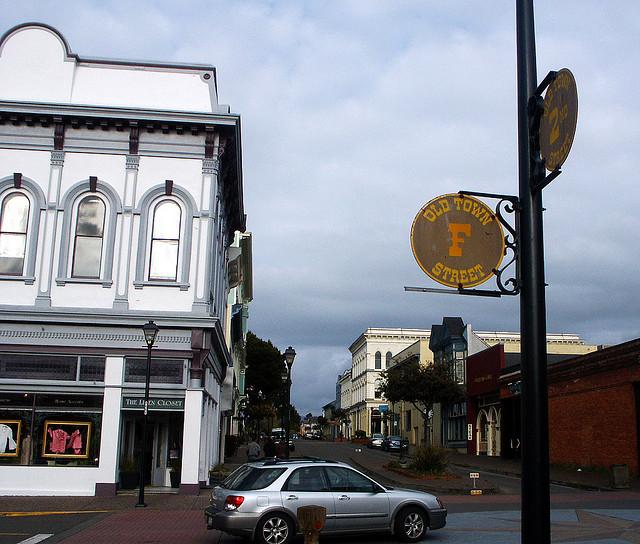What color is the car?
Write a very short answer. Silver. That letter is large on the sign?
Quick response, please. F. What kind of vehicle is shown?
Keep it brief. Car. 